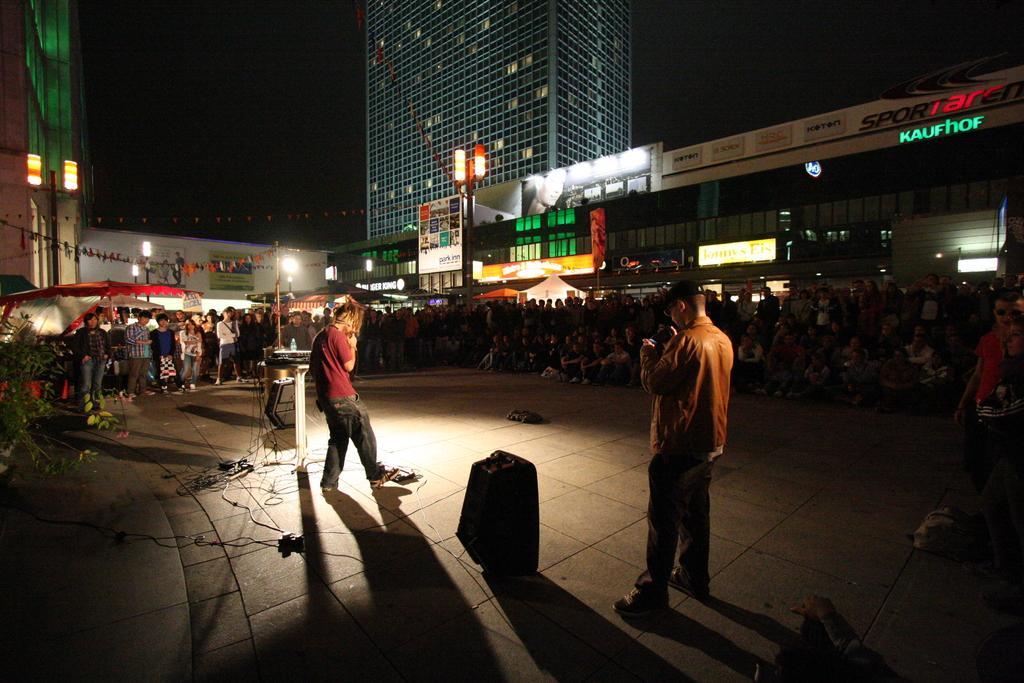In one or two sentences, can you explain what this image depicts? In this image, we can see two persons standing, there are some people sitting and some are standing. We can see some buildings and lights. 